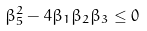Convert formula to latex. <formula><loc_0><loc_0><loc_500><loc_500>\beta _ { 5 } ^ { 2 } - 4 \beta _ { 1 } \beta _ { 2 } \beta _ { 3 } \leq 0</formula> 